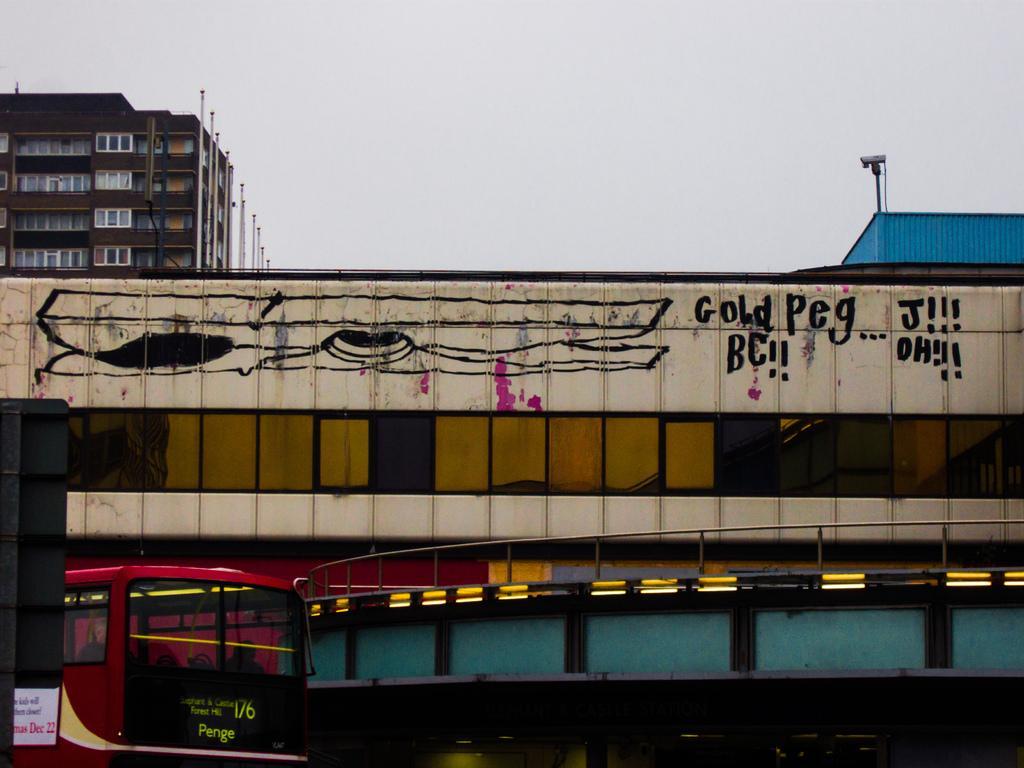Can you describe this image briefly? This picture is clicked outside the city. At the bottom of the picture, we see a red bus is moving on the road under the bridge. In the background, there are buildings which are in brown and blue color. At the top of the picture, we see the sky. 